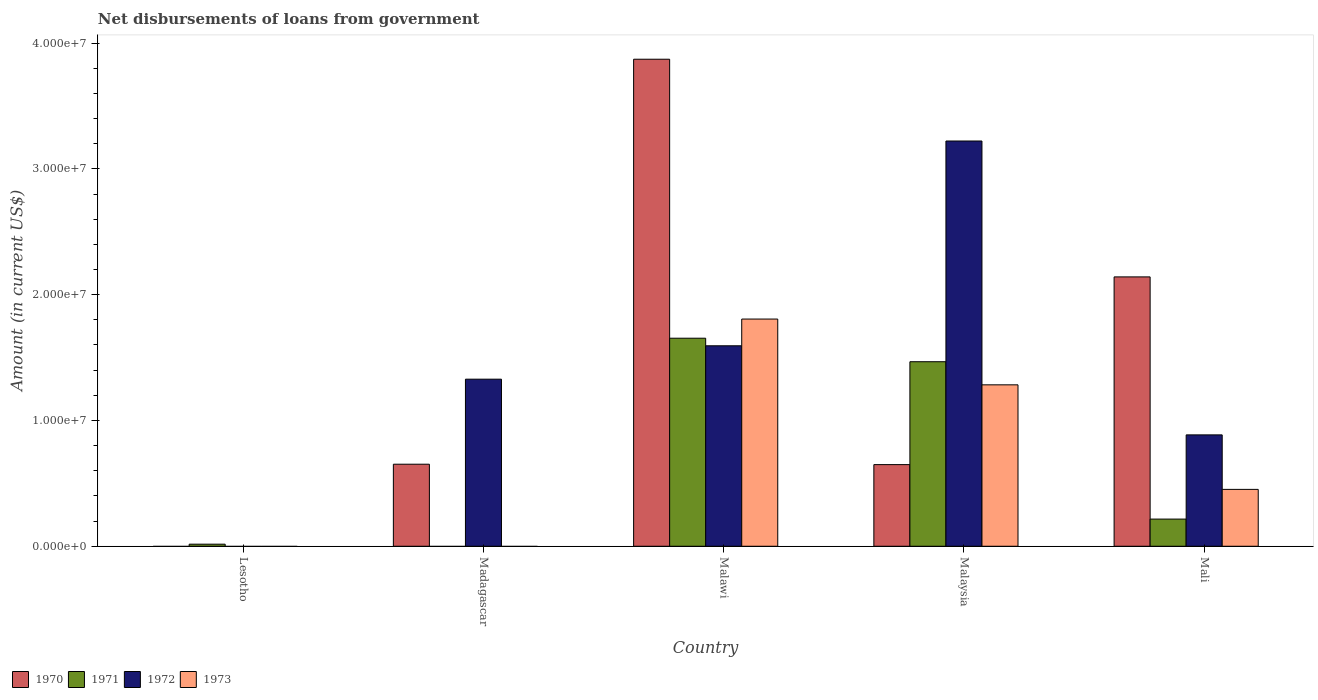How many different coloured bars are there?
Your answer should be very brief. 4. Are the number of bars per tick equal to the number of legend labels?
Give a very brief answer. No. Are the number of bars on each tick of the X-axis equal?
Keep it short and to the point. No. How many bars are there on the 5th tick from the right?
Provide a succinct answer. 1. What is the label of the 5th group of bars from the left?
Offer a terse response. Mali. In how many cases, is the number of bars for a given country not equal to the number of legend labels?
Your answer should be very brief. 2. What is the amount of loan disbursed from government in 1971 in Lesotho?
Offer a very short reply. 1.65e+05. Across all countries, what is the maximum amount of loan disbursed from government in 1973?
Provide a succinct answer. 1.81e+07. Across all countries, what is the minimum amount of loan disbursed from government in 1972?
Offer a very short reply. 0. In which country was the amount of loan disbursed from government in 1972 maximum?
Provide a succinct answer. Malaysia. What is the total amount of loan disbursed from government in 1972 in the graph?
Your response must be concise. 7.03e+07. What is the difference between the amount of loan disbursed from government in 1972 in Malaysia and that in Mali?
Ensure brevity in your answer.  2.34e+07. What is the difference between the amount of loan disbursed from government in 1971 in Malaysia and the amount of loan disbursed from government in 1973 in Madagascar?
Keep it short and to the point. 1.47e+07. What is the average amount of loan disbursed from government in 1971 per country?
Your response must be concise. 6.71e+06. What is the difference between the amount of loan disbursed from government of/in 1970 and amount of loan disbursed from government of/in 1972 in Malawi?
Your answer should be very brief. 2.28e+07. In how many countries, is the amount of loan disbursed from government in 1970 greater than 8000000 US$?
Your response must be concise. 2. What is the ratio of the amount of loan disbursed from government in 1971 in Lesotho to that in Malaysia?
Keep it short and to the point. 0.01. Is the difference between the amount of loan disbursed from government in 1970 in Madagascar and Malaysia greater than the difference between the amount of loan disbursed from government in 1972 in Madagascar and Malaysia?
Offer a very short reply. Yes. What is the difference between the highest and the second highest amount of loan disbursed from government in 1970?
Provide a short and direct response. 3.22e+07. What is the difference between the highest and the lowest amount of loan disbursed from government in 1971?
Ensure brevity in your answer.  1.65e+07. In how many countries, is the amount of loan disbursed from government in 1970 greater than the average amount of loan disbursed from government in 1970 taken over all countries?
Give a very brief answer. 2. Is it the case that in every country, the sum of the amount of loan disbursed from government in 1972 and amount of loan disbursed from government in 1970 is greater than the amount of loan disbursed from government in 1971?
Offer a terse response. No. How many bars are there?
Your response must be concise. 15. Are the values on the major ticks of Y-axis written in scientific E-notation?
Ensure brevity in your answer.  Yes. Does the graph contain any zero values?
Keep it short and to the point. Yes. How many legend labels are there?
Offer a very short reply. 4. How are the legend labels stacked?
Provide a succinct answer. Horizontal. What is the title of the graph?
Give a very brief answer. Net disbursements of loans from government. Does "1961" appear as one of the legend labels in the graph?
Your response must be concise. No. What is the label or title of the X-axis?
Provide a succinct answer. Country. What is the label or title of the Y-axis?
Your response must be concise. Amount (in current US$). What is the Amount (in current US$) in 1970 in Lesotho?
Provide a succinct answer. 0. What is the Amount (in current US$) in 1971 in Lesotho?
Offer a very short reply. 1.65e+05. What is the Amount (in current US$) of 1972 in Lesotho?
Offer a very short reply. 0. What is the Amount (in current US$) of 1973 in Lesotho?
Keep it short and to the point. 0. What is the Amount (in current US$) in 1970 in Madagascar?
Make the answer very short. 6.52e+06. What is the Amount (in current US$) in 1971 in Madagascar?
Give a very brief answer. 0. What is the Amount (in current US$) in 1972 in Madagascar?
Your response must be concise. 1.33e+07. What is the Amount (in current US$) in 1973 in Madagascar?
Your answer should be very brief. 0. What is the Amount (in current US$) of 1970 in Malawi?
Your response must be concise. 3.87e+07. What is the Amount (in current US$) in 1971 in Malawi?
Your response must be concise. 1.65e+07. What is the Amount (in current US$) of 1972 in Malawi?
Provide a short and direct response. 1.59e+07. What is the Amount (in current US$) of 1973 in Malawi?
Offer a terse response. 1.81e+07. What is the Amount (in current US$) of 1970 in Malaysia?
Keep it short and to the point. 6.49e+06. What is the Amount (in current US$) of 1971 in Malaysia?
Your answer should be compact. 1.47e+07. What is the Amount (in current US$) in 1972 in Malaysia?
Your answer should be very brief. 3.22e+07. What is the Amount (in current US$) of 1973 in Malaysia?
Your answer should be compact. 1.28e+07. What is the Amount (in current US$) of 1970 in Mali?
Your answer should be compact. 2.14e+07. What is the Amount (in current US$) in 1971 in Mali?
Your response must be concise. 2.16e+06. What is the Amount (in current US$) of 1972 in Mali?
Your response must be concise. 8.85e+06. What is the Amount (in current US$) in 1973 in Mali?
Offer a terse response. 4.52e+06. Across all countries, what is the maximum Amount (in current US$) in 1970?
Your answer should be compact. 3.87e+07. Across all countries, what is the maximum Amount (in current US$) of 1971?
Provide a succinct answer. 1.65e+07. Across all countries, what is the maximum Amount (in current US$) in 1972?
Provide a short and direct response. 3.22e+07. Across all countries, what is the maximum Amount (in current US$) of 1973?
Give a very brief answer. 1.81e+07. Across all countries, what is the minimum Amount (in current US$) in 1971?
Your answer should be compact. 0. Across all countries, what is the minimum Amount (in current US$) of 1973?
Your answer should be compact. 0. What is the total Amount (in current US$) of 1970 in the graph?
Make the answer very short. 7.31e+07. What is the total Amount (in current US$) in 1971 in the graph?
Your response must be concise. 3.35e+07. What is the total Amount (in current US$) of 1972 in the graph?
Keep it short and to the point. 7.03e+07. What is the total Amount (in current US$) in 1973 in the graph?
Ensure brevity in your answer.  3.54e+07. What is the difference between the Amount (in current US$) in 1971 in Lesotho and that in Malawi?
Give a very brief answer. -1.64e+07. What is the difference between the Amount (in current US$) of 1971 in Lesotho and that in Malaysia?
Your answer should be compact. -1.45e+07. What is the difference between the Amount (in current US$) in 1971 in Lesotho and that in Mali?
Make the answer very short. -1.99e+06. What is the difference between the Amount (in current US$) of 1970 in Madagascar and that in Malawi?
Provide a succinct answer. -3.22e+07. What is the difference between the Amount (in current US$) of 1972 in Madagascar and that in Malawi?
Keep it short and to the point. -2.65e+06. What is the difference between the Amount (in current US$) of 1970 in Madagascar and that in Malaysia?
Your answer should be compact. 3.20e+04. What is the difference between the Amount (in current US$) of 1972 in Madagascar and that in Malaysia?
Offer a very short reply. -1.89e+07. What is the difference between the Amount (in current US$) in 1970 in Madagascar and that in Mali?
Ensure brevity in your answer.  -1.49e+07. What is the difference between the Amount (in current US$) of 1972 in Madagascar and that in Mali?
Keep it short and to the point. 4.43e+06. What is the difference between the Amount (in current US$) in 1970 in Malawi and that in Malaysia?
Your answer should be compact. 3.22e+07. What is the difference between the Amount (in current US$) in 1971 in Malawi and that in Malaysia?
Offer a very short reply. 1.87e+06. What is the difference between the Amount (in current US$) of 1972 in Malawi and that in Malaysia?
Your answer should be very brief. -1.63e+07. What is the difference between the Amount (in current US$) of 1973 in Malawi and that in Malaysia?
Your answer should be very brief. 5.23e+06. What is the difference between the Amount (in current US$) of 1970 in Malawi and that in Mali?
Keep it short and to the point. 1.73e+07. What is the difference between the Amount (in current US$) in 1971 in Malawi and that in Mali?
Your answer should be compact. 1.44e+07. What is the difference between the Amount (in current US$) of 1972 in Malawi and that in Mali?
Ensure brevity in your answer.  7.08e+06. What is the difference between the Amount (in current US$) of 1973 in Malawi and that in Mali?
Give a very brief answer. 1.35e+07. What is the difference between the Amount (in current US$) in 1970 in Malaysia and that in Mali?
Your answer should be very brief. -1.49e+07. What is the difference between the Amount (in current US$) of 1971 in Malaysia and that in Mali?
Offer a terse response. 1.25e+07. What is the difference between the Amount (in current US$) in 1972 in Malaysia and that in Mali?
Provide a short and direct response. 2.34e+07. What is the difference between the Amount (in current US$) of 1973 in Malaysia and that in Mali?
Offer a terse response. 8.31e+06. What is the difference between the Amount (in current US$) of 1971 in Lesotho and the Amount (in current US$) of 1972 in Madagascar?
Provide a succinct answer. -1.31e+07. What is the difference between the Amount (in current US$) of 1971 in Lesotho and the Amount (in current US$) of 1972 in Malawi?
Make the answer very short. -1.58e+07. What is the difference between the Amount (in current US$) in 1971 in Lesotho and the Amount (in current US$) in 1973 in Malawi?
Provide a short and direct response. -1.79e+07. What is the difference between the Amount (in current US$) of 1971 in Lesotho and the Amount (in current US$) of 1972 in Malaysia?
Offer a very short reply. -3.20e+07. What is the difference between the Amount (in current US$) of 1971 in Lesotho and the Amount (in current US$) of 1973 in Malaysia?
Give a very brief answer. -1.27e+07. What is the difference between the Amount (in current US$) of 1971 in Lesotho and the Amount (in current US$) of 1972 in Mali?
Your answer should be compact. -8.69e+06. What is the difference between the Amount (in current US$) in 1971 in Lesotho and the Amount (in current US$) in 1973 in Mali?
Make the answer very short. -4.36e+06. What is the difference between the Amount (in current US$) in 1970 in Madagascar and the Amount (in current US$) in 1971 in Malawi?
Provide a short and direct response. -1.00e+07. What is the difference between the Amount (in current US$) in 1970 in Madagascar and the Amount (in current US$) in 1972 in Malawi?
Provide a short and direct response. -9.41e+06. What is the difference between the Amount (in current US$) in 1970 in Madagascar and the Amount (in current US$) in 1973 in Malawi?
Offer a terse response. -1.15e+07. What is the difference between the Amount (in current US$) of 1972 in Madagascar and the Amount (in current US$) of 1973 in Malawi?
Give a very brief answer. -4.78e+06. What is the difference between the Amount (in current US$) in 1970 in Madagascar and the Amount (in current US$) in 1971 in Malaysia?
Offer a terse response. -8.15e+06. What is the difference between the Amount (in current US$) of 1970 in Madagascar and the Amount (in current US$) of 1972 in Malaysia?
Your response must be concise. -2.57e+07. What is the difference between the Amount (in current US$) in 1970 in Madagascar and the Amount (in current US$) in 1973 in Malaysia?
Give a very brief answer. -6.31e+06. What is the difference between the Amount (in current US$) of 1970 in Madagascar and the Amount (in current US$) of 1971 in Mali?
Your answer should be very brief. 4.36e+06. What is the difference between the Amount (in current US$) of 1970 in Madagascar and the Amount (in current US$) of 1972 in Mali?
Provide a short and direct response. -2.33e+06. What is the difference between the Amount (in current US$) in 1970 in Madagascar and the Amount (in current US$) in 1973 in Mali?
Your answer should be compact. 2.00e+06. What is the difference between the Amount (in current US$) of 1972 in Madagascar and the Amount (in current US$) of 1973 in Mali?
Give a very brief answer. 8.76e+06. What is the difference between the Amount (in current US$) in 1970 in Malawi and the Amount (in current US$) in 1971 in Malaysia?
Your response must be concise. 2.40e+07. What is the difference between the Amount (in current US$) of 1970 in Malawi and the Amount (in current US$) of 1972 in Malaysia?
Provide a short and direct response. 6.50e+06. What is the difference between the Amount (in current US$) in 1970 in Malawi and the Amount (in current US$) in 1973 in Malaysia?
Provide a succinct answer. 2.59e+07. What is the difference between the Amount (in current US$) of 1971 in Malawi and the Amount (in current US$) of 1972 in Malaysia?
Make the answer very short. -1.57e+07. What is the difference between the Amount (in current US$) of 1971 in Malawi and the Amount (in current US$) of 1973 in Malaysia?
Your answer should be compact. 3.71e+06. What is the difference between the Amount (in current US$) in 1972 in Malawi and the Amount (in current US$) in 1973 in Malaysia?
Provide a short and direct response. 3.10e+06. What is the difference between the Amount (in current US$) in 1970 in Malawi and the Amount (in current US$) in 1971 in Mali?
Your answer should be compact. 3.66e+07. What is the difference between the Amount (in current US$) in 1970 in Malawi and the Amount (in current US$) in 1972 in Mali?
Keep it short and to the point. 2.99e+07. What is the difference between the Amount (in current US$) of 1970 in Malawi and the Amount (in current US$) of 1973 in Mali?
Provide a short and direct response. 3.42e+07. What is the difference between the Amount (in current US$) of 1971 in Malawi and the Amount (in current US$) of 1972 in Mali?
Give a very brief answer. 7.68e+06. What is the difference between the Amount (in current US$) in 1971 in Malawi and the Amount (in current US$) in 1973 in Mali?
Offer a very short reply. 1.20e+07. What is the difference between the Amount (in current US$) in 1972 in Malawi and the Amount (in current US$) in 1973 in Mali?
Give a very brief answer. 1.14e+07. What is the difference between the Amount (in current US$) of 1970 in Malaysia and the Amount (in current US$) of 1971 in Mali?
Provide a short and direct response. 4.33e+06. What is the difference between the Amount (in current US$) in 1970 in Malaysia and the Amount (in current US$) in 1972 in Mali?
Provide a short and direct response. -2.36e+06. What is the difference between the Amount (in current US$) in 1970 in Malaysia and the Amount (in current US$) in 1973 in Mali?
Provide a succinct answer. 1.97e+06. What is the difference between the Amount (in current US$) in 1971 in Malaysia and the Amount (in current US$) in 1972 in Mali?
Offer a terse response. 5.82e+06. What is the difference between the Amount (in current US$) in 1971 in Malaysia and the Amount (in current US$) in 1973 in Mali?
Provide a short and direct response. 1.01e+07. What is the difference between the Amount (in current US$) of 1972 in Malaysia and the Amount (in current US$) of 1973 in Mali?
Offer a very short reply. 2.77e+07. What is the average Amount (in current US$) in 1970 per country?
Your response must be concise. 1.46e+07. What is the average Amount (in current US$) in 1971 per country?
Your response must be concise. 6.71e+06. What is the average Amount (in current US$) of 1972 per country?
Provide a short and direct response. 1.41e+07. What is the average Amount (in current US$) in 1973 per country?
Provide a short and direct response. 7.08e+06. What is the difference between the Amount (in current US$) of 1970 and Amount (in current US$) of 1972 in Madagascar?
Your answer should be very brief. -6.76e+06. What is the difference between the Amount (in current US$) in 1970 and Amount (in current US$) in 1971 in Malawi?
Keep it short and to the point. 2.22e+07. What is the difference between the Amount (in current US$) of 1970 and Amount (in current US$) of 1972 in Malawi?
Offer a very short reply. 2.28e+07. What is the difference between the Amount (in current US$) of 1970 and Amount (in current US$) of 1973 in Malawi?
Keep it short and to the point. 2.07e+07. What is the difference between the Amount (in current US$) in 1971 and Amount (in current US$) in 1972 in Malawi?
Keep it short and to the point. 6.02e+05. What is the difference between the Amount (in current US$) in 1971 and Amount (in current US$) in 1973 in Malawi?
Provide a short and direct response. -1.52e+06. What is the difference between the Amount (in current US$) in 1972 and Amount (in current US$) in 1973 in Malawi?
Your answer should be compact. -2.12e+06. What is the difference between the Amount (in current US$) in 1970 and Amount (in current US$) in 1971 in Malaysia?
Offer a very short reply. -8.18e+06. What is the difference between the Amount (in current US$) of 1970 and Amount (in current US$) of 1972 in Malaysia?
Offer a terse response. -2.57e+07. What is the difference between the Amount (in current US$) in 1970 and Amount (in current US$) in 1973 in Malaysia?
Give a very brief answer. -6.34e+06. What is the difference between the Amount (in current US$) of 1971 and Amount (in current US$) of 1972 in Malaysia?
Ensure brevity in your answer.  -1.75e+07. What is the difference between the Amount (in current US$) of 1971 and Amount (in current US$) of 1973 in Malaysia?
Keep it short and to the point. 1.84e+06. What is the difference between the Amount (in current US$) of 1972 and Amount (in current US$) of 1973 in Malaysia?
Offer a terse response. 1.94e+07. What is the difference between the Amount (in current US$) in 1970 and Amount (in current US$) in 1971 in Mali?
Offer a very short reply. 1.93e+07. What is the difference between the Amount (in current US$) of 1970 and Amount (in current US$) of 1972 in Mali?
Your response must be concise. 1.26e+07. What is the difference between the Amount (in current US$) in 1970 and Amount (in current US$) in 1973 in Mali?
Your answer should be very brief. 1.69e+07. What is the difference between the Amount (in current US$) in 1971 and Amount (in current US$) in 1972 in Mali?
Your response must be concise. -6.70e+06. What is the difference between the Amount (in current US$) of 1971 and Amount (in current US$) of 1973 in Mali?
Ensure brevity in your answer.  -2.36e+06. What is the difference between the Amount (in current US$) in 1972 and Amount (in current US$) in 1973 in Mali?
Keep it short and to the point. 4.33e+06. What is the ratio of the Amount (in current US$) of 1971 in Lesotho to that in Malaysia?
Make the answer very short. 0.01. What is the ratio of the Amount (in current US$) in 1971 in Lesotho to that in Mali?
Provide a short and direct response. 0.08. What is the ratio of the Amount (in current US$) of 1970 in Madagascar to that in Malawi?
Offer a very short reply. 0.17. What is the ratio of the Amount (in current US$) in 1972 in Madagascar to that in Malawi?
Your answer should be compact. 0.83. What is the ratio of the Amount (in current US$) in 1972 in Madagascar to that in Malaysia?
Provide a succinct answer. 0.41. What is the ratio of the Amount (in current US$) in 1970 in Madagascar to that in Mali?
Give a very brief answer. 0.3. What is the ratio of the Amount (in current US$) in 1972 in Madagascar to that in Mali?
Your response must be concise. 1.5. What is the ratio of the Amount (in current US$) in 1970 in Malawi to that in Malaysia?
Your answer should be very brief. 5.97. What is the ratio of the Amount (in current US$) of 1971 in Malawi to that in Malaysia?
Make the answer very short. 1.13. What is the ratio of the Amount (in current US$) of 1972 in Malawi to that in Malaysia?
Your answer should be compact. 0.49. What is the ratio of the Amount (in current US$) in 1973 in Malawi to that in Malaysia?
Ensure brevity in your answer.  1.41. What is the ratio of the Amount (in current US$) of 1970 in Malawi to that in Mali?
Your response must be concise. 1.81. What is the ratio of the Amount (in current US$) of 1971 in Malawi to that in Mali?
Ensure brevity in your answer.  7.66. What is the ratio of the Amount (in current US$) of 1972 in Malawi to that in Mali?
Give a very brief answer. 1.8. What is the ratio of the Amount (in current US$) of 1973 in Malawi to that in Mali?
Keep it short and to the point. 3.99. What is the ratio of the Amount (in current US$) in 1970 in Malaysia to that in Mali?
Your answer should be compact. 0.3. What is the ratio of the Amount (in current US$) of 1971 in Malaysia to that in Mali?
Offer a terse response. 6.79. What is the ratio of the Amount (in current US$) of 1972 in Malaysia to that in Mali?
Your answer should be compact. 3.64. What is the ratio of the Amount (in current US$) in 1973 in Malaysia to that in Mali?
Provide a short and direct response. 2.84. What is the difference between the highest and the second highest Amount (in current US$) of 1970?
Your answer should be very brief. 1.73e+07. What is the difference between the highest and the second highest Amount (in current US$) in 1971?
Give a very brief answer. 1.87e+06. What is the difference between the highest and the second highest Amount (in current US$) in 1972?
Ensure brevity in your answer.  1.63e+07. What is the difference between the highest and the second highest Amount (in current US$) in 1973?
Offer a very short reply. 5.23e+06. What is the difference between the highest and the lowest Amount (in current US$) of 1970?
Your answer should be compact. 3.87e+07. What is the difference between the highest and the lowest Amount (in current US$) in 1971?
Offer a very short reply. 1.65e+07. What is the difference between the highest and the lowest Amount (in current US$) of 1972?
Offer a very short reply. 3.22e+07. What is the difference between the highest and the lowest Amount (in current US$) in 1973?
Provide a short and direct response. 1.81e+07. 